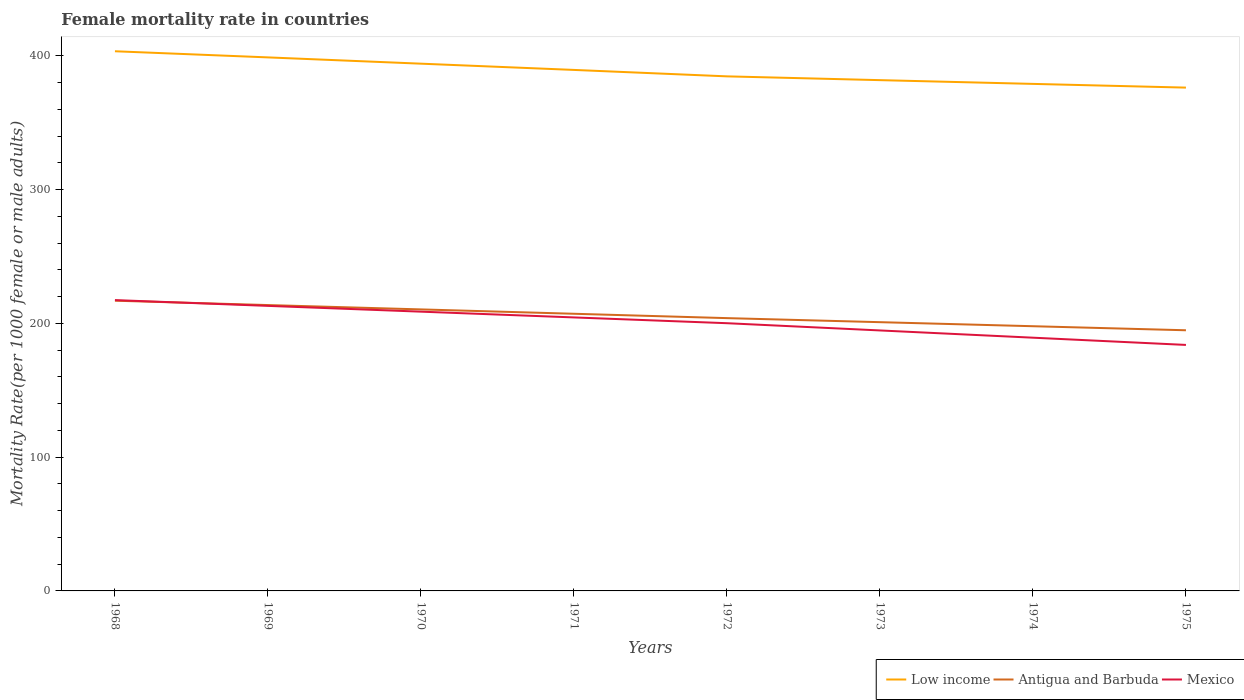How many different coloured lines are there?
Make the answer very short. 3. Is the number of lines equal to the number of legend labels?
Provide a succinct answer. Yes. Across all years, what is the maximum female mortality rate in Low income?
Provide a succinct answer. 376.25. In which year was the female mortality rate in Mexico maximum?
Your answer should be compact. 1975. What is the total female mortality rate in Low income in the graph?
Your response must be concise. 24.4. What is the difference between the highest and the second highest female mortality rate in Antigua and Barbuda?
Give a very brief answer. 22.1. Is the female mortality rate in Low income strictly greater than the female mortality rate in Mexico over the years?
Keep it short and to the point. No. What is the difference between two consecutive major ticks on the Y-axis?
Offer a terse response. 100. Are the values on the major ticks of Y-axis written in scientific E-notation?
Provide a succinct answer. No. Does the graph contain grids?
Ensure brevity in your answer.  No. What is the title of the graph?
Keep it short and to the point. Female mortality rate in countries. What is the label or title of the X-axis?
Give a very brief answer. Years. What is the label or title of the Y-axis?
Ensure brevity in your answer.  Mortality Rate(per 1000 female or male adults). What is the Mortality Rate(per 1000 female or male adults) in Low income in 1968?
Your response must be concise. 403.42. What is the Mortality Rate(per 1000 female or male adults) in Antigua and Barbuda in 1968?
Your response must be concise. 216.95. What is the Mortality Rate(per 1000 female or male adults) in Mexico in 1968?
Give a very brief answer. 217.41. What is the Mortality Rate(per 1000 female or male adults) of Low income in 1969?
Provide a succinct answer. 398.84. What is the Mortality Rate(per 1000 female or male adults) in Antigua and Barbuda in 1969?
Your answer should be compact. 213.7. What is the Mortality Rate(per 1000 female or male adults) in Mexico in 1969?
Give a very brief answer. 213.09. What is the Mortality Rate(per 1000 female or male adults) in Low income in 1970?
Make the answer very short. 394.14. What is the Mortality Rate(per 1000 female or male adults) of Antigua and Barbuda in 1970?
Offer a terse response. 210.44. What is the Mortality Rate(per 1000 female or male adults) of Mexico in 1970?
Your response must be concise. 208.77. What is the Mortality Rate(per 1000 female or male adults) in Low income in 1971?
Offer a very short reply. 389.47. What is the Mortality Rate(per 1000 female or male adults) in Antigua and Barbuda in 1971?
Your response must be concise. 207.19. What is the Mortality Rate(per 1000 female or male adults) in Mexico in 1971?
Your response must be concise. 204.45. What is the Mortality Rate(per 1000 female or male adults) in Low income in 1972?
Offer a terse response. 384.65. What is the Mortality Rate(per 1000 female or male adults) in Antigua and Barbuda in 1972?
Offer a terse response. 203.93. What is the Mortality Rate(per 1000 female or male adults) in Mexico in 1972?
Provide a short and direct response. 200.13. What is the Mortality Rate(per 1000 female or male adults) in Low income in 1973?
Offer a very short reply. 381.83. What is the Mortality Rate(per 1000 female or male adults) in Antigua and Barbuda in 1973?
Your answer should be compact. 200.9. What is the Mortality Rate(per 1000 female or male adults) of Mexico in 1973?
Give a very brief answer. 194.72. What is the Mortality Rate(per 1000 female or male adults) in Low income in 1974?
Offer a very short reply. 379.02. What is the Mortality Rate(per 1000 female or male adults) of Antigua and Barbuda in 1974?
Provide a succinct answer. 197.88. What is the Mortality Rate(per 1000 female or male adults) in Mexico in 1974?
Your answer should be compact. 189.31. What is the Mortality Rate(per 1000 female or male adults) in Low income in 1975?
Keep it short and to the point. 376.25. What is the Mortality Rate(per 1000 female or male adults) in Antigua and Barbuda in 1975?
Keep it short and to the point. 194.85. What is the Mortality Rate(per 1000 female or male adults) of Mexico in 1975?
Your response must be concise. 183.89. Across all years, what is the maximum Mortality Rate(per 1000 female or male adults) of Low income?
Offer a terse response. 403.42. Across all years, what is the maximum Mortality Rate(per 1000 female or male adults) of Antigua and Barbuda?
Your answer should be compact. 216.95. Across all years, what is the maximum Mortality Rate(per 1000 female or male adults) of Mexico?
Provide a short and direct response. 217.41. Across all years, what is the minimum Mortality Rate(per 1000 female or male adults) of Low income?
Offer a terse response. 376.25. Across all years, what is the minimum Mortality Rate(per 1000 female or male adults) in Antigua and Barbuda?
Offer a very short reply. 194.85. Across all years, what is the minimum Mortality Rate(per 1000 female or male adults) of Mexico?
Your response must be concise. 183.89. What is the total Mortality Rate(per 1000 female or male adults) in Low income in the graph?
Offer a terse response. 3107.63. What is the total Mortality Rate(per 1000 female or male adults) of Antigua and Barbuda in the graph?
Provide a short and direct response. 1645.84. What is the total Mortality Rate(per 1000 female or male adults) of Mexico in the graph?
Your answer should be compact. 1611.76. What is the difference between the Mortality Rate(per 1000 female or male adults) in Low income in 1968 and that in 1969?
Your answer should be compact. 4.59. What is the difference between the Mortality Rate(per 1000 female or male adults) in Antigua and Barbuda in 1968 and that in 1969?
Provide a succinct answer. 3.25. What is the difference between the Mortality Rate(per 1000 female or male adults) in Mexico in 1968 and that in 1969?
Keep it short and to the point. 4.32. What is the difference between the Mortality Rate(per 1000 female or male adults) in Low income in 1968 and that in 1970?
Your response must be concise. 9.28. What is the difference between the Mortality Rate(per 1000 female or male adults) of Antigua and Barbuda in 1968 and that in 1970?
Offer a very short reply. 6.51. What is the difference between the Mortality Rate(per 1000 female or male adults) of Mexico in 1968 and that in 1970?
Offer a terse response. 8.64. What is the difference between the Mortality Rate(per 1000 female or male adults) in Low income in 1968 and that in 1971?
Provide a short and direct response. 13.95. What is the difference between the Mortality Rate(per 1000 female or male adults) in Antigua and Barbuda in 1968 and that in 1971?
Your response must be concise. 9.77. What is the difference between the Mortality Rate(per 1000 female or male adults) in Mexico in 1968 and that in 1971?
Provide a succinct answer. 12.96. What is the difference between the Mortality Rate(per 1000 female or male adults) of Low income in 1968 and that in 1972?
Your answer should be compact. 18.77. What is the difference between the Mortality Rate(per 1000 female or male adults) in Antigua and Barbuda in 1968 and that in 1972?
Offer a very short reply. 13.02. What is the difference between the Mortality Rate(per 1000 female or male adults) in Mexico in 1968 and that in 1972?
Your answer should be very brief. 17.28. What is the difference between the Mortality Rate(per 1000 female or male adults) in Low income in 1968 and that in 1973?
Offer a terse response. 21.59. What is the difference between the Mortality Rate(per 1000 female or male adults) in Antigua and Barbuda in 1968 and that in 1973?
Keep it short and to the point. 16.05. What is the difference between the Mortality Rate(per 1000 female or male adults) in Mexico in 1968 and that in 1973?
Make the answer very short. 22.69. What is the difference between the Mortality Rate(per 1000 female or male adults) in Low income in 1968 and that in 1974?
Ensure brevity in your answer.  24.4. What is the difference between the Mortality Rate(per 1000 female or male adults) of Antigua and Barbuda in 1968 and that in 1974?
Give a very brief answer. 19.07. What is the difference between the Mortality Rate(per 1000 female or male adults) in Mexico in 1968 and that in 1974?
Provide a short and direct response. 28.1. What is the difference between the Mortality Rate(per 1000 female or male adults) of Low income in 1968 and that in 1975?
Make the answer very short. 27.17. What is the difference between the Mortality Rate(per 1000 female or male adults) in Antigua and Barbuda in 1968 and that in 1975?
Provide a short and direct response. 22.1. What is the difference between the Mortality Rate(per 1000 female or male adults) of Mexico in 1968 and that in 1975?
Offer a very short reply. 33.51. What is the difference between the Mortality Rate(per 1000 female or male adults) of Low income in 1969 and that in 1970?
Offer a terse response. 4.69. What is the difference between the Mortality Rate(per 1000 female or male adults) of Antigua and Barbuda in 1969 and that in 1970?
Give a very brief answer. 3.25. What is the difference between the Mortality Rate(per 1000 female or male adults) in Mexico in 1969 and that in 1970?
Your answer should be compact. 4.32. What is the difference between the Mortality Rate(per 1000 female or male adults) in Low income in 1969 and that in 1971?
Ensure brevity in your answer.  9.36. What is the difference between the Mortality Rate(per 1000 female or male adults) of Antigua and Barbuda in 1969 and that in 1971?
Give a very brief answer. 6.51. What is the difference between the Mortality Rate(per 1000 female or male adults) in Mexico in 1969 and that in 1971?
Your answer should be compact. 8.64. What is the difference between the Mortality Rate(per 1000 female or male adults) of Low income in 1969 and that in 1972?
Ensure brevity in your answer.  14.18. What is the difference between the Mortality Rate(per 1000 female or male adults) in Antigua and Barbuda in 1969 and that in 1972?
Keep it short and to the point. 9.77. What is the difference between the Mortality Rate(per 1000 female or male adults) of Mexico in 1969 and that in 1972?
Offer a very short reply. 12.96. What is the difference between the Mortality Rate(per 1000 female or male adults) of Low income in 1969 and that in 1973?
Your answer should be very brief. 17. What is the difference between the Mortality Rate(per 1000 female or male adults) in Antigua and Barbuda in 1969 and that in 1973?
Provide a short and direct response. 12.79. What is the difference between the Mortality Rate(per 1000 female or male adults) in Mexico in 1969 and that in 1973?
Keep it short and to the point. 18.37. What is the difference between the Mortality Rate(per 1000 female or male adults) in Low income in 1969 and that in 1974?
Ensure brevity in your answer.  19.81. What is the difference between the Mortality Rate(per 1000 female or male adults) of Antigua and Barbuda in 1969 and that in 1974?
Keep it short and to the point. 15.82. What is the difference between the Mortality Rate(per 1000 female or male adults) in Mexico in 1969 and that in 1974?
Provide a short and direct response. 23.78. What is the difference between the Mortality Rate(per 1000 female or male adults) of Low income in 1969 and that in 1975?
Your response must be concise. 22.59. What is the difference between the Mortality Rate(per 1000 female or male adults) in Antigua and Barbuda in 1969 and that in 1975?
Your answer should be compact. 18.84. What is the difference between the Mortality Rate(per 1000 female or male adults) in Mexico in 1969 and that in 1975?
Your answer should be compact. 29.19. What is the difference between the Mortality Rate(per 1000 female or male adults) of Low income in 1970 and that in 1971?
Make the answer very short. 4.67. What is the difference between the Mortality Rate(per 1000 female or male adults) in Antigua and Barbuda in 1970 and that in 1971?
Make the answer very short. 3.26. What is the difference between the Mortality Rate(per 1000 female or male adults) in Mexico in 1970 and that in 1971?
Provide a short and direct response. 4.32. What is the difference between the Mortality Rate(per 1000 female or male adults) of Low income in 1970 and that in 1972?
Your response must be concise. 9.49. What is the difference between the Mortality Rate(per 1000 female or male adults) in Antigua and Barbuda in 1970 and that in 1972?
Keep it short and to the point. 6.51. What is the difference between the Mortality Rate(per 1000 female or male adults) of Mexico in 1970 and that in 1972?
Offer a very short reply. 8.64. What is the difference between the Mortality Rate(per 1000 female or male adults) of Low income in 1970 and that in 1973?
Offer a very short reply. 12.31. What is the difference between the Mortality Rate(per 1000 female or male adults) in Antigua and Barbuda in 1970 and that in 1973?
Ensure brevity in your answer.  9.54. What is the difference between the Mortality Rate(per 1000 female or male adults) in Mexico in 1970 and that in 1973?
Offer a very short reply. 14.05. What is the difference between the Mortality Rate(per 1000 female or male adults) of Low income in 1970 and that in 1974?
Offer a very short reply. 15.12. What is the difference between the Mortality Rate(per 1000 female or male adults) in Antigua and Barbuda in 1970 and that in 1974?
Your answer should be very brief. 12.56. What is the difference between the Mortality Rate(per 1000 female or male adults) in Mexico in 1970 and that in 1974?
Offer a very short reply. 19.46. What is the difference between the Mortality Rate(per 1000 female or male adults) of Low income in 1970 and that in 1975?
Your answer should be compact. 17.9. What is the difference between the Mortality Rate(per 1000 female or male adults) in Antigua and Barbuda in 1970 and that in 1975?
Your response must be concise. 15.59. What is the difference between the Mortality Rate(per 1000 female or male adults) in Mexico in 1970 and that in 1975?
Keep it short and to the point. 24.87. What is the difference between the Mortality Rate(per 1000 female or male adults) of Low income in 1971 and that in 1972?
Give a very brief answer. 4.82. What is the difference between the Mortality Rate(per 1000 female or male adults) of Antigua and Barbuda in 1971 and that in 1972?
Your answer should be compact. 3.25. What is the difference between the Mortality Rate(per 1000 female or male adults) of Mexico in 1971 and that in 1972?
Your response must be concise. 4.32. What is the difference between the Mortality Rate(per 1000 female or male adults) in Low income in 1971 and that in 1973?
Give a very brief answer. 7.64. What is the difference between the Mortality Rate(per 1000 female or male adults) in Antigua and Barbuda in 1971 and that in 1973?
Your response must be concise. 6.28. What is the difference between the Mortality Rate(per 1000 female or male adults) of Mexico in 1971 and that in 1973?
Offer a terse response. 9.73. What is the difference between the Mortality Rate(per 1000 female or male adults) of Low income in 1971 and that in 1974?
Keep it short and to the point. 10.45. What is the difference between the Mortality Rate(per 1000 female or male adults) of Antigua and Barbuda in 1971 and that in 1974?
Your response must be concise. 9.31. What is the difference between the Mortality Rate(per 1000 female or male adults) of Mexico in 1971 and that in 1974?
Make the answer very short. 15.14. What is the difference between the Mortality Rate(per 1000 female or male adults) in Low income in 1971 and that in 1975?
Provide a succinct answer. 13.23. What is the difference between the Mortality Rate(per 1000 female or male adults) in Antigua and Barbuda in 1971 and that in 1975?
Offer a terse response. 12.33. What is the difference between the Mortality Rate(per 1000 female or male adults) of Mexico in 1971 and that in 1975?
Your answer should be very brief. 20.55. What is the difference between the Mortality Rate(per 1000 female or male adults) of Low income in 1972 and that in 1973?
Ensure brevity in your answer.  2.82. What is the difference between the Mortality Rate(per 1000 female or male adults) in Antigua and Barbuda in 1972 and that in 1973?
Ensure brevity in your answer.  3.03. What is the difference between the Mortality Rate(per 1000 female or male adults) in Mexico in 1972 and that in 1973?
Provide a succinct answer. 5.41. What is the difference between the Mortality Rate(per 1000 female or male adults) of Low income in 1972 and that in 1974?
Give a very brief answer. 5.63. What is the difference between the Mortality Rate(per 1000 female or male adults) in Antigua and Barbuda in 1972 and that in 1974?
Offer a very short reply. 6.05. What is the difference between the Mortality Rate(per 1000 female or male adults) of Mexico in 1972 and that in 1974?
Offer a very short reply. 10.82. What is the difference between the Mortality Rate(per 1000 female or male adults) in Low income in 1972 and that in 1975?
Provide a short and direct response. 8.41. What is the difference between the Mortality Rate(per 1000 female or male adults) in Antigua and Barbuda in 1972 and that in 1975?
Offer a very short reply. 9.08. What is the difference between the Mortality Rate(per 1000 female or male adults) of Mexico in 1972 and that in 1975?
Give a very brief answer. 16.23. What is the difference between the Mortality Rate(per 1000 female or male adults) of Low income in 1973 and that in 1974?
Offer a very short reply. 2.81. What is the difference between the Mortality Rate(per 1000 female or male adults) in Antigua and Barbuda in 1973 and that in 1974?
Your response must be concise. 3.03. What is the difference between the Mortality Rate(per 1000 female or male adults) of Mexico in 1973 and that in 1974?
Give a very brief answer. 5.41. What is the difference between the Mortality Rate(per 1000 female or male adults) in Low income in 1973 and that in 1975?
Give a very brief answer. 5.59. What is the difference between the Mortality Rate(per 1000 female or male adults) in Antigua and Barbuda in 1973 and that in 1975?
Keep it short and to the point. 6.05. What is the difference between the Mortality Rate(per 1000 female or male adults) in Mexico in 1973 and that in 1975?
Your answer should be compact. 10.82. What is the difference between the Mortality Rate(per 1000 female or male adults) in Low income in 1974 and that in 1975?
Your response must be concise. 2.78. What is the difference between the Mortality Rate(per 1000 female or male adults) in Antigua and Barbuda in 1974 and that in 1975?
Provide a succinct answer. 3.03. What is the difference between the Mortality Rate(per 1000 female or male adults) in Mexico in 1974 and that in 1975?
Your answer should be compact. 5.41. What is the difference between the Mortality Rate(per 1000 female or male adults) of Low income in 1968 and the Mortality Rate(per 1000 female or male adults) of Antigua and Barbuda in 1969?
Offer a very short reply. 189.73. What is the difference between the Mortality Rate(per 1000 female or male adults) of Low income in 1968 and the Mortality Rate(per 1000 female or male adults) of Mexico in 1969?
Your answer should be compact. 190.33. What is the difference between the Mortality Rate(per 1000 female or male adults) in Antigua and Barbuda in 1968 and the Mortality Rate(per 1000 female or male adults) in Mexico in 1969?
Your response must be concise. 3.86. What is the difference between the Mortality Rate(per 1000 female or male adults) in Low income in 1968 and the Mortality Rate(per 1000 female or male adults) in Antigua and Barbuda in 1970?
Provide a short and direct response. 192.98. What is the difference between the Mortality Rate(per 1000 female or male adults) in Low income in 1968 and the Mortality Rate(per 1000 female or male adults) in Mexico in 1970?
Offer a very short reply. 194.65. What is the difference between the Mortality Rate(per 1000 female or male adults) of Antigua and Barbuda in 1968 and the Mortality Rate(per 1000 female or male adults) of Mexico in 1970?
Your answer should be very brief. 8.18. What is the difference between the Mortality Rate(per 1000 female or male adults) in Low income in 1968 and the Mortality Rate(per 1000 female or male adults) in Antigua and Barbuda in 1971?
Ensure brevity in your answer.  196.24. What is the difference between the Mortality Rate(per 1000 female or male adults) of Low income in 1968 and the Mortality Rate(per 1000 female or male adults) of Mexico in 1971?
Your response must be concise. 198.97. What is the difference between the Mortality Rate(per 1000 female or male adults) in Antigua and Barbuda in 1968 and the Mortality Rate(per 1000 female or male adults) in Mexico in 1971?
Keep it short and to the point. 12.5. What is the difference between the Mortality Rate(per 1000 female or male adults) in Low income in 1968 and the Mortality Rate(per 1000 female or male adults) in Antigua and Barbuda in 1972?
Your answer should be compact. 199.49. What is the difference between the Mortality Rate(per 1000 female or male adults) of Low income in 1968 and the Mortality Rate(per 1000 female or male adults) of Mexico in 1972?
Offer a very short reply. 203.29. What is the difference between the Mortality Rate(per 1000 female or male adults) of Antigua and Barbuda in 1968 and the Mortality Rate(per 1000 female or male adults) of Mexico in 1972?
Your answer should be very brief. 16.82. What is the difference between the Mortality Rate(per 1000 female or male adults) in Low income in 1968 and the Mortality Rate(per 1000 female or male adults) in Antigua and Barbuda in 1973?
Keep it short and to the point. 202.52. What is the difference between the Mortality Rate(per 1000 female or male adults) of Low income in 1968 and the Mortality Rate(per 1000 female or male adults) of Mexico in 1973?
Provide a succinct answer. 208.7. What is the difference between the Mortality Rate(per 1000 female or male adults) of Antigua and Barbuda in 1968 and the Mortality Rate(per 1000 female or male adults) of Mexico in 1973?
Provide a short and direct response. 22.23. What is the difference between the Mortality Rate(per 1000 female or male adults) of Low income in 1968 and the Mortality Rate(per 1000 female or male adults) of Antigua and Barbuda in 1974?
Offer a very short reply. 205.54. What is the difference between the Mortality Rate(per 1000 female or male adults) in Low income in 1968 and the Mortality Rate(per 1000 female or male adults) in Mexico in 1974?
Make the answer very short. 214.12. What is the difference between the Mortality Rate(per 1000 female or male adults) in Antigua and Barbuda in 1968 and the Mortality Rate(per 1000 female or male adults) in Mexico in 1974?
Offer a very short reply. 27.64. What is the difference between the Mortality Rate(per 1000 female or male adults) in Low income in 1968 and the Mortality Rate(per 1000 female or male adults) in Antigua and Barbuda in 1975?
Ensure brevity in your answer.  208.57. What is the difference between the Mortality Rate(per 1000 female or male adults) of Low income in 1968 and the Mortality Rate(per 1000 female or male adults) of Mexico in 1975?
Offer a terse response. 219.53. What is the difference between the Mortality Rate(per 1000 female or male adults) in Antigua and Barbuda in 1968 and the Mortality Rate(per 1000 female or male adults) in Mexico in 1975?
Offer a very short reply. 33.06. What is the difference between the Mortality Rate(per 1000 female or male adults) in Low income in 1969 and the Mortality Rate(per 1000 female or male adults) in Antigua and Barbuda in 1970?
Ensure brevity in your answer.  188.4. What is the difference between the Mortality Rate(per 1000 female or male adults) in Low income in 1969 and the Mortality Rate(per 1000 female or male adults) in Mexico in 1970?
Your answer should be very brief. 190.07. What is the difference between the Mortality Rate(per 1000 female or male adults) in Antigua and Barbuda in 1969 and the Mortality Rate(per 1000 female or male adults) in Mexico in 1970?
Your answer should be compact. 4.93. What is the difference between the Mortality Rate(per 1000 female or male adults) in Low income in 1969 and the Mortality Rate(per 1000 female or male adults) in Antigua and Barbuda in 1971?
Ensure brevity in your answer.  191.65. What is the difference between the Mortality Rate(per 1000 female or male adults) in Low income in 1969 and the Mortality Rate(per 1000 female or male adults) in Mexico in 1971?
Make the answer very short. 194.39. What is the difference between the Mortality Rate(per 1000 female or male adults) of Antigua and Barbuda in 1969 and the Mortality Rate(per 1000 female or male adults) of Mexico in 1971?
Your answer should be very brief. 9.25. What is the difference between the Mortality Rate(per 1000 female or male adults) in Low income in 1969 and the Mortality Rate(per 1000 female or male adults) in Antigua and Barbuda in 1972?
Offer a terse response. 194.91. What is the difference between the Mortality Rate(per 1000 female or male adults) of Low income in 1969 and the Mortality Rate(per 1000 female or male adults) of Mexico in 1972?
Your response must be concise. 198.71. What is the difference between the Mortality Rate(per 1000 female or male adults) in Antigua and Barbuda in 1969 and the Mortality Rate(per 1000 female or male adults) in Mexico in 1972?
Offer a terse response. 13.57. What is the difference between the Mortality Rate(per 1000 female or male adults) in Low income in 1969 and the Mortality Rate(per 1000 female or male adults) in Antigua and Barbuda in 1973?
Keep it short and to the point. 197.93. What is the difference between the Mortality Rate(per 1000 female or male adults) in Low income in 1969 and the Mortality Rate(per 1000 female or male adults) in Mexico in 1973?
Offer a very short reply. 204.12. What is the difference between the Mortality Rate(per 1000 female or male adults) in Antigua and Barbuda in 1969 and the Mortality Rate(per 1000 female or male adults) in Mexico in 1973?
Keep it short and to the point. 18.98. What is the difference between the Mortality Rate(per 1000 female or male adults) of Low income in 1969 and the Mortality Rate(per 1000 female or male adults) of Antigua and Barbuda in 1974?
Your answer should be compact. 200.96. What is the difference between the Mortality Rate(per 1000 female or male adults) of Low income in 1969 and the Mortality Rate(per 1000 female or male adults) of Mexico in 1974?
Keep it short and to the point. 209.53. What is the difference between the Mortality Rate(per 1000 female or male adults) in Antigua and Barbuda in 1969 and the Mortality Rate(per 1000 female or male adults) in Mexico in 1974?
Keep it short and to the point. 24.39. What is the difference between the Mortality Rate(per 1000 female or male adults) of Low income in 1969 and the Mortality Rate(per 1000 female or male adults) of Antigua and Barbuda in 1975?
Your answer should be compact. 203.98. What is the difference between the Mortality Rate(per 1000 female or male adults) of Low income in 1969 and the Mortality Rate(per 1000 female or male adults) of Mexico in 1975?
Keep it short and to the point. 214.94. What is the difference between the Mortality Rate(per 1000 female or male adults) in Antigua and Barbuda in 1969 and the Mortality Rate(per 1000 female or male adults) in Mexico in 1975?
Your answer should be compact. 29.8. What is the difference between the Mortality Rate(per 1000 female or male adults) of Low income in 1970 and the Mortality Rate(per 1000 female or male adults) of Antigua and Barbuda in 1971?
Offer a very short reply. 186.96. What is the difference between the Mortality Rate(per 1000 female or male adults) of Low income in 1970 and the Mortality Rate(per 1000 female or male adults) of Mexico in 1971?
Make the answer very short. 189.69. What is the difference between the Mortality Rate(per 1000 female or male adults) in Antigua and Barbuda in 1970 and the Mortality Rate(per 1000 female or male adults) in Mexico in 1971?
Make the answer very short. 5.99. What is the difference between the Mortality Rate(per 1000 female or male adults) in Low income in 1970 and the Mortality Rate(per 1000 female or male adults) in Antigua and Barbuda in 1972?
Provide a short and direct response. 190.21. What is the difference between the Mortality Rate(per 1000 female or male adults) in Low income in 1970 and the Mortality Rate(per 1000 female or male adults) in Mexico in 1972?
Offer a terse response. 194.01. What is the difference between the Mortality Rate(per 1000 female or male adults) in Antigua and Barbuda in 1970 and the Mortality Rate(per 1000 female or male adults) in Mexico in 1972?
Give a very brief answer. 10.31. What is the difference between the Mortality Rate(per 1000 female or male adults) in Low income in 1970 and the Mortality Rate(per 1000 female or male adults) in Antigua and Barbuda in 1973?
Offer a terse response. 193.24. What is the difference between the Mortality Rate(per 1000 female or male adults) of Low income in 1970 and the Mortality Rate(per 1000 female or male adults) of Mexico in 1973?
Your answer should be compact. 199.43. What is the difference between the Mortality Rate(per 1000 female or male adults) in Antigua and Barbuda in 1970 and the Mortality Rate(per 1000 female or male adults) in Mexico in 1973?
Offer a very short reply. 15.72. What is the difference between the Mortality Rate(per 1000 female or male adults) of Low income in 1970 and the Mortality Rate(per 1000 female or male adults) of Antigua and Barbuda in 1974?
Keep it short and to the point. 196.26. What is the difference between the Mortality Rate(per 1000 female or male adults) in Low income in 1970 and the Mortality Rate(per 1000 female or male adults) in Mexico in 1974?
Provide a short and direct response. 204.84. What is the difference between the Mortality Rate(per 1000 female or male adults) in Antigua and Barbuda in 1970 and the Mortality Rate(per 1000 female or male adults) in Mexico in 1974?
Provide a succinct answer. 21.14. What is the difference between the Mortality Rate(per 1000 female or male adults) in Low income in 1970 and the Mortality Rate(per 1000 female or male adults) in Antigua and Barbuda in 1975?
Keep it short and to the point. 199.29. What is the difference between the Mortality Rate(per 1000 female or male adults) in Low income in 1970 and the Mortality Rate(per 1000 female or male adults) in Mexico in 1975?
Ensure brevity in your answer.  210.25. What is the difference between the Mortality Rate(per 1000 female or male adults) of Antigua and Barbuda in 1970 and the Mortality Rate(per 1000 female or male adults) of Mexico in 1975?
Keep it short and to the point. 26.55. What is the difference between the Mortality Rate(per 1000 female or male adults) in Low income in 1971 and the Mortality Rate(per 1000 female or male adults) in Antigua and Barbuda in 1972?
Give a very brief answer. 185.54. What is the difference between the Mortality Rate(per 1000 female or male adults) of Low income in 1971 and the Mortality Rate(per 1000 female or male adults) of Mexico in 1972?
Keep it short and to the point. 189.34. What is the difference between the Mortality Rate(per 1000 female or male adults) of Antigua and Barbuda in 1971 and the Mortality Rate(per 1000 female or male adults) of Mexico in 1972?
Make the answer very short. 7.06. What is the difference between the Mortality Rate(per 1000 female or male adults) of Low income in 1971 and the Mortality Rate(per 1000 female or male adults) of Antigua and Barbuda in 1973?
Offer a terse response. 188.57. What is the difference between the Mortality Rate(per 1000 female or male adults) in Low income in 1971 and the Mortality Rate(per 1000 female or male adults) in Mexico in 1973?
Offer a very short reply. 194.76. What is the difference between the Mortality Rate(per 1000 female or male adults) of Antigua and Barbuda in 1971 and the Mortality Rate(per 1000 female or male adults) of Mexico in 1973?
Keep it short and to the point. 12.47. What is the difference between the Mortality Rate(per 1000 female or male adults) of Low income in 1971 and the Mortality Rate(per 1000 female or male adults) of Antigua and Barbuda in 1974?
Ensure brevity in your answer.  191.6. What is the difference between the Mortality Rate(per 1000 female or male adults) in Low income in 1971 and the Mortality Rate(per 1000 female or male adults) in Mexico in 1974?
Your answer should be compact. 200.17. What is the difference between the Mortality Rate(per 1000 female or male adults) of Antigua and Barbuda in 1971 and the Mortality Rate(per 1000 female or male adults) of Mexico in 1974?
Ensure brevity in your answer.  17.88. What is the difference between the Mortality Rate(per 1000 female or male adults) of Low income in 1971 and the Mortality Rate(per 1000 female or male adults) of Antigua and Barbuda in 1975?
Your response must be concise. 194.62. What is the difference between the Mortality Rate(per 1000 female or male adults) in Low income in 1971 and the Mortality Rate(per 1000 female or male adults) in Mexico in 1975?
Provide a short and direct response. 205.58. What is the difference between the Mortality Rate(per 1000 female or male adults) in Antigua and Barbuda in 1971 and the Mortality Rate(per 1000 female or male adults) in Mexico in 1975?
Ensure brevity in your answer.  23.29. What is the difference between the Mortality Rate(per 1000 female or male adults) in Low income in 1972 and the Mortality Rate(per 1000 female or male adults) in Antigua and Barbuda in 1973?
Provide a short and direct response. 183.75. What is the difference between the Mortality Rate(per 1000 female or male adults) of Low income in 1972 and the Mortality Rate(per 1000 female or male adults) of Mexico in 1973?
Keep it short and to the point. 189.94. What is the difference between the Mortality Rate(per 1000 female or male adults) in Antigua and Barbuda in 1972 and the Mortality Rate(per 1000 female or male adults) in Mexico in 1973?
Provide a short and direct response. 9.21. What is the difference between the Mortality Rate(per 1000 female or male adults) of Low income in 1972 and the Mortality Rate(per 1000 female or male adults) of Antigua and Barbuda in 1974?
Make the answer very short. 186.78. What is the difference between the Mortality Rate(per 1000 female or male adults) in Low income in 1972 and the Mortality Rate(per 1000 female or male adults) in Mexico in 1974?
Ensure brevity in your answer.  195.35. What is the difference between the Mortality Rate(per 1000 female or male adults) in Antigua and Barbuda in 1972 and the Mortality Rate(per 1000 female or male adults) in Mexico in 1974?
Your response must be concise. 14.62. What is the difference between the Mortality Rate(per 1000 female or male adults) in Low income in 1972 and the Mortality Rate(per 1000 female or male adults) in Antigua and Barbuda in 1975?
Keep it short and to the point. 189.8. What is the difference between the Mortality Rate(per 1000 female or male adults) in Low income in 1972 and the Mortality Rate(per 1000 female or male adults) in Mexico in 1975?
Ensure brevity in your answer.  200.76. What is the difference between the Mortality Rate(per 1000 female or male adults) in Antigua and Barbuda in 1972 and the Mortality Rate(per 1000 female or male adults) in Mexico in 1975?
Make the answer very short. 20.04. What is the difference between the Mortality Rate(per 1000 female or male adults) of Low income in 1973 and the Mortality Rate(per 1000 female or male adults) of Antigua and Barbuda in 1974?
Offer a very short reply. 183.96. What is the difference between the Mortality Rate(per 1000 female or male adults) of Low income in 1973 and the Mortality Rate(per 1000 female or male adults) of Mexico in 1974?
Make the answer very short. 192.53. What is the difference between the Mortality Rate(per 1000 female or male adults) in Antigua and Barbuda in 1973 and the Mortality Rate(per 1000 female or male adults) in Mexico in 1974?
Your answer should be compact. 11.6. What is the difference between the Mortality Rate(per 1000 female or male adults) in Low income in 1973 and the Mortality Rate(per 1000 female or male adults) in Antigua and Barbuda in 1975?
Make the answer very short. 186.98. What is the difference between the Mortality Rate(per 1000 female or male adults) of Low income in 1973 and the Mortality Rate(per 1000 female or male adults) of Mexico in 1975?
Provide a short and direct response. 197.94. What is the difference between the Mortality Rate(per 1000 female or male adults) in Antigua and Barbuda in 1973 and the Mortality Rate(per 1000 female or male adults) in Mexico in 1975?
Give a very brief answer. 17.01. What is the difference between the Mortality Rate(per 1000 female or male adults) of Low income in 1974 and the Mortality Rate(per 1000 female or male adults) of Antigua and Barbuda in 1975?
Provide a succinct answer. 184.17. What is the difference between the Mortality Rate(per 1000 female or male adults) in Low income in 1974 and the Mortality Rate(per 1000 female or male adults) in Mexico in 1975?
Keep it short and to the point. 195.13. What is the difference between the Mortality Rate(per 1000 female or male adults) of Antigua and Barbuda in 1974 and the Mortality Rate(per 1000 female or male adults) of Mexico in 1975?
Make the answer very short. 13.98. What is the average Mortality Rate(per 1000 female or male adults) in Low income per year?
Make the answer very short. 388.45. What is the average Mortality Rate(per 1000 female or male adults) in Antigua and Barbuda per year?
Give a very brief answer. 205.73. What is the average Mortality Rate(per 1000 female or male adults) of Mexico per year?
Your answer should be very brief. 201.47. In the year 1968, what is the difference between the Mortality Rate(per 1000 female or male adults) in Low income and Mortality Rate(per 1000 female or male adults) in Antigua and Barbuda?
Your answer should be compact. 186.47. In the year 1968, what is the difference between the Mortality Rate(per 1000 female or male adults) in Low income and Mortality Rate(per 1000 female or male adults) in Mexico?
Provide a short and direct response. 186.01. In the year 1968, what is the difference between the Mortality Rate(per 1000 female or male adults) of Antigua and Barbuda and Mortality Rate(per 1000 female or male adults) of Mexico?
Your response must be concise. -0.46. In the year 1969, what is the difference between the Mortality Rate(per 1000 female or male adults) of Low income and Mortality Rate(per 1000 female or male adults) of Antigua and Barbuda?
Offer a terse response. 185.14. In the year 1969, what is the difference between the Mortality Rate(per 1000 female or male adults) in Low income and Mortality Rate(per 1000 female or male adults) in Mexico?
Your answer should be compact. 185.75. In the year 1969, what is the difference between the Mortality Rate(per 1000 female or male adults) in Antigua and Barbuda and Mortality Rate(per 1000 female or male adults) in Mexico?
Make the answer very short. 0.61. In the year 1970, what is the difference between the Mortality Rate(per 1000 female or male adults) in Low income and Mortality Rate(per 1000 female or male adults) in Antigua and Barbuda?
Provide a short and direct response. 183.7. In the year 1970, what is the difference between the Mortality Rate(per 1000 female or male adults) in Low income and Mortality Rate(per 1000 female or male adults) in Mexico?
Your answer should be compact. 185.37. In the year 1970, what is the difference between the Mortality Rate(per 1000 female or male adults) of Antigua and Barbuda and Mortality Rate(per 1000 female or male adults) of Mexico?
Make the answer very short. 1.67. In the year 1971, what is the difference between the Mortality Rate(per 1000 female or male adults) of Low income and Mortality Rate(per 1000 female or male adults) of Antigua and Barbuda?
Offer a terse response. 182.29. In the year 1971, what is the difference between the Mortality Rate(per 1000 female or male adults) of Low income and Mortality Rate(per 1000 female or male adults) of Mexico?
Offer a terse response. 185.02. In the year 1971, what is the difference between the Mortality Rate(per 1000 female or male adults) in Antigua and Barbuda and Mortality Rate(per 1000 female or male adults) in Mexico?
Keep it short and to the point. 2.74. In the year 1972, what is the difference between the Mortality Rate(per 1000 female or male adults) in Low income and Mortality Rate(per 1000 female or male adults) in Antigua and Barbuda?
Offer a terse response. 180.72. In the year 1972, what is the difference between the Mortality Rate(per 1000 female or male adults) in Low income and Mortality Rate(per 1000 female or male adults) in Mexico?
Your answer should be compact. 184.52. In the year 1972, what is the difference between the Mortality Rate(per 1000 female or male adults) of Antigua and Barbuda and Mortality Rate(per 1000 female or male adults) of Mexico?
Give a very brief answer. 3.8. In the year 1973, what is the difference between the Mortality Rate(per 1000 female or male adults) of Low income and Mortality Rate(per 1000 female or male adults) of Antigua and Barbuda?
Your response must be concise. 180.93. In the year 1973, what is the difference between the Mortality Rate(per 1000 female or male adults) of Low income and Mortality Rate(per 1000 female or male adults) of Mexico?
Your answer should be compact. 187.12. In the year 1973, what is the difference between the Mortality Rate(per 1000 female or male adults) in Antigua and Barbuda and Mortality Rate(per 1000 female or male adults) in Mexico?
Offer a very short reply. 6.19. In the year 1974, what is the difference between the Mortality Rate(per 1000 female or male adults) of Low income and Mortality Rate(per 1000 female or male adults) of Antigua and Barbuda?
Provide a succinct answer. 181.15. In the year 1974, what is the difference between the Mortality Rate(per 1000 female or male adults) of Low income and Mortality Rate(per 1000 female or male adults) of Mexico?
Your answer should be very brief. 189.72. In the year 1974, what is the difference between the Mortality Rate(per 1000 female or male adults) of Antigua and Barbuda and Mortality Rate(per 1000 female or male adults) of Mexico?
Provide a succinct answer. 8.57. In the year 1975, what is the difference between the Mortality Rate(per 1000 female or male adults) in Low income and Mortality Rate(per 1000 female or male adults) in Antigua and Barbuda?
Your answer should be very brief. 181.4. In the year 1975, what is the difference between the Mortality Rate(per 1000 female or male adults) in Low income and Mortality Rate(per 1000 female or male adults) in Mexico?
Keep it short and to the point. 192.35. In the year 1975, what is the difference between the Mortality Rate(per 1000 female or male adults) of Antigua and Barbuda and Mortality Rate(per 1000 female or male adults) of Mexico?
Provide a short and direct response. 10.96. What is the ratio of the Mortality Rate(per 1000 female or male adults) in Low income in 1968 to that in 1969?
Offer a terse response. 1.01. What is the ratio of the Mortality Rate(per 1000 female or male adults) in Antigua and Barbuda in 1968 to that in 1969?
Offer a terse response. 1.02. What is the ratio of the Mortality Rate(per 1000 female or male adults) of Mexico in 1968 to that in 1969?
Offer a very short reply. 1.02. What is the ratio of the Mortality Rate(per 1000 female or male adults) of Low income in 1968 to that in 1970?
Make the answer very short. 1.02. What is the ratio of the Mortality Rate(per 1000 female or male adults) of Antigua and Barbuda in 1968 to that in 1970?
Your response must be concise. 1.03. What is the ratio of the Mortality Rate(per 1000 female or male adults) in Mexico in 1968 to that in 1970?
Your answer should be very brief. 1.04. What is the ratio of the Mortality Rate(per 1000 female or male adults) in Low income in 1968 to that in 1971?
Offer a very short reply. 1.04. What is the ratio of the Mortality Rate(per 1000 female or male adults) in Antigua and Barbuda in 1968 to that in 1971?
Your response must be concise. 1.05. What is the ratio of the Mortality Rate(per 1000 female or male adults) of Mexico in 1968 to that in 1971?
Your response must be concise. 1.06. What is the ratio of the Mortality Rate(per 1000 female or male adults) in Low income in 1968 to that in 1972?
Make the answer very short. 1.05. What is the ratio of the Mortality Rate(per 1000 female or male adults) in Antigua and Barbuda in 1968 to that in 1972?
Offer a terse response. 1.06. What is the ratio of the Mortality Rate(per 1000 female or male adults) of Mexico in 1968 to that in 1972?
Keep it short and to the point. 1.09. What is the ratio of the Mortality Rate(per 1000 female or male adults) of Low income in 1968 to that in 1973?
Your answer should be very brief. 1.06. What is the ratio of the Mortality Rate(per 1000 female or male adults) in Antigua and Barbuda in 1968 to that in 1973?
Offer a very short reply. 1.08. What is the ratio of the Mortality Rate(per 1000 female or male adults) in Mexico in 1968 to that in 1973?
Your answer should be very brief. 1.12. What is the ratio of the Mortality Rate(per 1000 female or male adults) in Low income in 1968 to that in 1974?
Offer a terse response. 1.06. What is the ratio of the Mortality Rate(per 1000 female or male adults) in Antigua and Barbuda in 1968 to that in 1974?
Provide a succinct answer. 1.1. What is the ratio of the Mortality Rate(per 1000 female or male adults) in Mexico in 1968 to that in 1974?
Your response must be concise. 1.15. What is the ratio of the Mortality Rate(per 1000 female or male adults) in Low income in 1968 to that in 1975?
Make the answer very short. 1.07. What is the ratio of the Mortality Rate(per 1000 female or male adults) in Antigua and Barbuda in 1968 to that in 1975?
Ensure brevity in your answer.  1.11. What is the ratio of the Mortality Rate(per 1000 female or male adults) of Mexico in 1968 to that in 1975?
Your response must be concise. 1.18. What is the ratio of the Mortality Rate(per 1000 female or male adults) of Low income in 1969 to that in 1970?
Offer a terse response. 1.01. What is the ratio of the Mortality Rate(per 1000 female or male adults) in Antigua and Barbuda in 1969 to that in 1970?
Offer a very short reply. 1.02. What is the ratio of the Mortality Rate(per 1000 female or male adults) of Mexico in 1969 to that in 1970?
Your answer should be very brief. 1.02. What is the ratio of the Mortality Rate(per 1000 female or male adults) in Low income in 1969 to that in 1971?
Ensure brevity in your answer.  1.02. What is the ratio of the Mortality Rate(per 1000 female or male adults) of Antigua and Barbuda in 1969 to that in 1971?
Keep it short and to the point. 1.03. What is the ratio of the Mortality Rate(per 1000 female or male adults) in Mexico in 1969 to that in 1971?
Offer a very short reply. 1.04. What is the ratio of the Mortality Rate(per 1000 female or male adults) of Low income in 1969 to that in 1972?
Offer a very short reply. 1.04. What is the ratio of the Mortality Rate(per 1000 female or male adults) of Antigua and Barbuda in 1969 to that in 1972?
Offer a terse response. 1.05. What is the ratio of the Mortality Rate(per 1000 female or male adults) in Mexico in 1969 to that in 1972?
Provide a short and direct response. 1.06. What is the ratio of the Mortality Rate(per 1000 female or male adults) in Low income in 1969 to that in 1973?
Your answer should be very brief. 1.04. What is the ratio of the Mortality Rate(per 1000 female or male adults) of Antigua and Barbuda in 1969 to that in 1973?
Offer a very short reply. 1.06. What is the ratio of the Mortality Rate(per 1000 female or male adults) in Mexico in 1969 to that in 1973?
Offer a terse response. 1.09. What is the ratio of the Mortality Rate(per 1000 female or male adults) in Low income in 1969 to that in 1974?
Ensure brevity in your answer.  1.05. What is the ratio of the Mortality Rate(per 1000 female or male adults) in Antigua and Barbuda in 1969 to that in 1974?
Your answer should be very brief. 1.08. What is the ratio of the Mortality Rate(per 1000 female or male adults) of Mexico in 1969 to that in 1974?
Your response must be concise. 1.13. What is the ratio of the Mortality Rate(per 1000 female or male adults) of Low income in 1969 to that in 1975?
Provide a short and direct response. 1.06. What is the ratio of the Mortality Rate(per 1000 female or male adults) of Antigua and Barbuda in 1969 to that in 1975?
Offer a very short reply. 1.1. What is the ratio of the Mortality Rate(per 1000 female or male adults) of Mexico in 1969 to that in 1975?
Give a very brief answer. 1.16. What is the ratio of the Mortality Rate(per 1000 female or male adults) of Antigua and Barbuda in 1970 to that in 1971?
Offer a very short reply. 1.02. What is the ratio of the Mortality Rate(per 1000 female or male adults) in Mexico in 1970 to that in 1971?
Your response must be concise. 1.02. What is the ratio of the Mortality Rate(per 1000 female or male adults) of Low income in 1970 to that in 1972?
Provide a succinct answer. 1.02. What is the ratio of the Mortality Rate(per 1000 female or male adults) of Antigua and Barbuda in 1970 to that in 1972?
Offer a very short reply. 1.03. What is the ratio of the Mortality Rate(per 1000 female or male adults) in Mexico in 1970 to that in 1972?
Make the answer very short. 1.04. What is the ratio of the Mortality Rate(per 1000 female or male adults) in Low income in 1970 to that in 1973?
Ensure brevity in your answer.  1.03. What is the ratio of the Mortality Rate(per 1000 female or male adults) in Antigua and Barbuda in 1970 to that in 1973?
Your answer should be compact. 1.05. What is the ratio of the Mortality Rate(per 1000 female or male adults) in Mexico in 1970 to that in 1973?
Provide a short and direct response. 1.07. What is the ratio of the Mortality Rate(per 1000 female or male adults) in Low income in 1970 to that in 1974?
Provide a succinct answer. 1.04. What is the ratio of the Mortality Rate(per 1000 female or male adults) of Antigua and Barbuda in 1970 to that in 1974?
Your answer should be very brief. 1.06. What is the ratio of the Mortality Rate(per 1000 female or male adults) in Mexico in 1970 to that in 1974?
Offer a terse response. 1.1. What is the ratio of the Mortality Rate(per 1000 female or male adults) of Low income in 1970 to that in 1975?
Your answer should be very brief. 1.05. What is the ratio of the Mortality Rate(per 1000 female or male adults) in Antigua and Barbuda in 1970 to that in 1975?
Your answer should be compact. 1.08. What is the ratio of the Mortality Rate(per 1000 female or male adults) of Mexico in 1970 to that in 1975?
Keep it short and to the point. 1.14. What is the ratio of the Mortality Rate(per 1000 female or male adults) in Low income in 1971 to that in 1972?
Your response must be concise. 1.01. What is the ratio of the Mortality Rate(per 1000 female or male adults) in Mexico in 1971 to that in 1972?
Provide a short and direct response. 1.02. What is the ratio of the Mortality Rate(per 1000 female or male adults) in Low income in 1971 to that in 1973?
Keep it short and to the point. 1.02. What is the ratio of the Mortality Rate(per 1000 female or male adults) of Antigua and Barbuda in 1971 to that in 1973?
Your response must be concise. 1.03. What is the ratio of the Mortality Rate(per 1000 female or male adults) in Mexico in 1971 to that in 1973?
Your answer should be compact. 1.05. What is the ratio of the Mortality Rate(per 1000 female or male adults) in Low income in 1971 to that in 1974?
Your answer should be compact. 1.03. What is the ratio of the Mortality Rate(per 1000 female or male adults) in Antigua and Barbuda in 1971 to that in 1974?
Provide a short and direct response. 1.05. What is the ratio of the Mortality Rate(per 1000 female or male adults) of Low income in 1971 to that in 1975?
Your response must be concise. 1.04. What is the ratio of the Mortality Rate(per 1000 female or male adults) in Antigua and Barbuda in 1971 to that in 1975?
Keep it short and to the point. 1.06. What is the ratio of the Mortality Rate(per 1000 female or male adults) of Mexico in 1971 to that in 1975?
Your answer should be compact. 1.11. What is the ratio of the Mortality Rate(per 1000 female or male adults) in Low income in 1972 to that in 1973?
Offer a terse response. 1.01. What is the ratio of the Mortality Rate(per 1000 female or male adults) of Antigua and Barbuda in 1972 to that in 1973?
Provide a succinct answer. 1.02. What is the ratio of the Mortality Rate(per 1000 female or male adults) of Mexico in 1972 to that in 1973?
Make the answer very short. 1.03. What is the ratio of the Mortality Rate(per 1000 female or male adults) in Low income in 1972 to that in 1974?
Keep it short and to the point. 1.01. What is the ratio of the Mortality Rate(per 1000 female or male adults) in Antigua and Barbuda in 1972 to that in 1974?
Ensure brevity in your answer.  1.03. What is the ratio of the Mortality Rate(per 1000 female or male adults) of Mexico in 1972 to that in 1974?
Keep it short and to the point. 1.06. What is the ratio of the Mortality Rate(per 1000 female or male adults) of Low income in 1972 to that in 1975?
Provide a short and direct response. 1.02. What is the ratio of the Mortality Rate(per 1000 female or male adults) of Antigua and Barbuda in 1972 to that in 1975?
Give a very brief answer. 1.05. What is the ratio of the Mortality Rate(per 1000 female or male adults) of Mexico in 1972 to that in 1975?
Make the answer very short. 1.09. What is the ratio of the Mortality Rate(per 1000 female or male adults) of Low income in 1973 to that in 1974?
Your answer should be compact. 1.01. What is the ratio of the Mortality Rate(per 1000 female or male adults) of Antigua and Barbuda in 1973 to that in 1974?
Provide a short and direct response. 1.02. What is the ratio of the Mortality Rate(per 1000 female or male adults) of Mexico in 1973 to that in 1974?
Make the answer very short. 1.03. What is the ratio of the Mortality Rate(per 1000 female or male adults) of Low income in 1973 to that in 1975?
Your response must be concise. 1.01. What is the ratio of the Mortality Rate(per 1000 female or male adults) of Antigua and Barbuda in 1973 to that in 1975?
Make the answer very short. 1.03. What is the ratio of the Mortality Rate(per 1000 female or male adults) of Mexico in 1973 to that in 1975?
Make the answer very short. 1.06. What is the ratio of the Mortality Rate(per 1000 female or male adults) in Low income in 1974 to that in 1975?
Keep it short and to the point. 1.01. What is the ratio of the Mortality Rate(per 1000 female or male adults) in Antigua and Barbuda in 1974 to that in 1975?
Offer a very short reply. 1.02. What is the ratio of the Mortality Rate(per 1000 female or male adults) of Mexico in 1974 to that in 1975?
Make the answer very short. 1.03. What is the difference between the highest and the second highest Mortality Rate(per 1000 female or male adults) of Low income?
Give a very brief answer. 4.59. What is the difference between the highest and the second highest Mortality Rate(per 1000 female or male adults) in Antigua and Barbuda?
Your response must be concise. 3.25. What is the difference between the highest and the second highest Mortality Rate(per 1000 female or male adults) of Mexico?
Ensure brevity in your answer.  4.32. What is the difference between the highest and the lowest Mortality Rate(per 1000 female or male adults) in Low income?
Your answer should be very brief. 27.17. What is the difference between the highest and the lowest Mortality Rate(per 1000 female or male adults) of Antigua and Barbuda?
Give a very brief answer. 22.1. What is the difference between the highest and the lowest Mortality Rate(per 1000 female or male adults) of Mexico?
Your answer should be very brief. 33.51. 